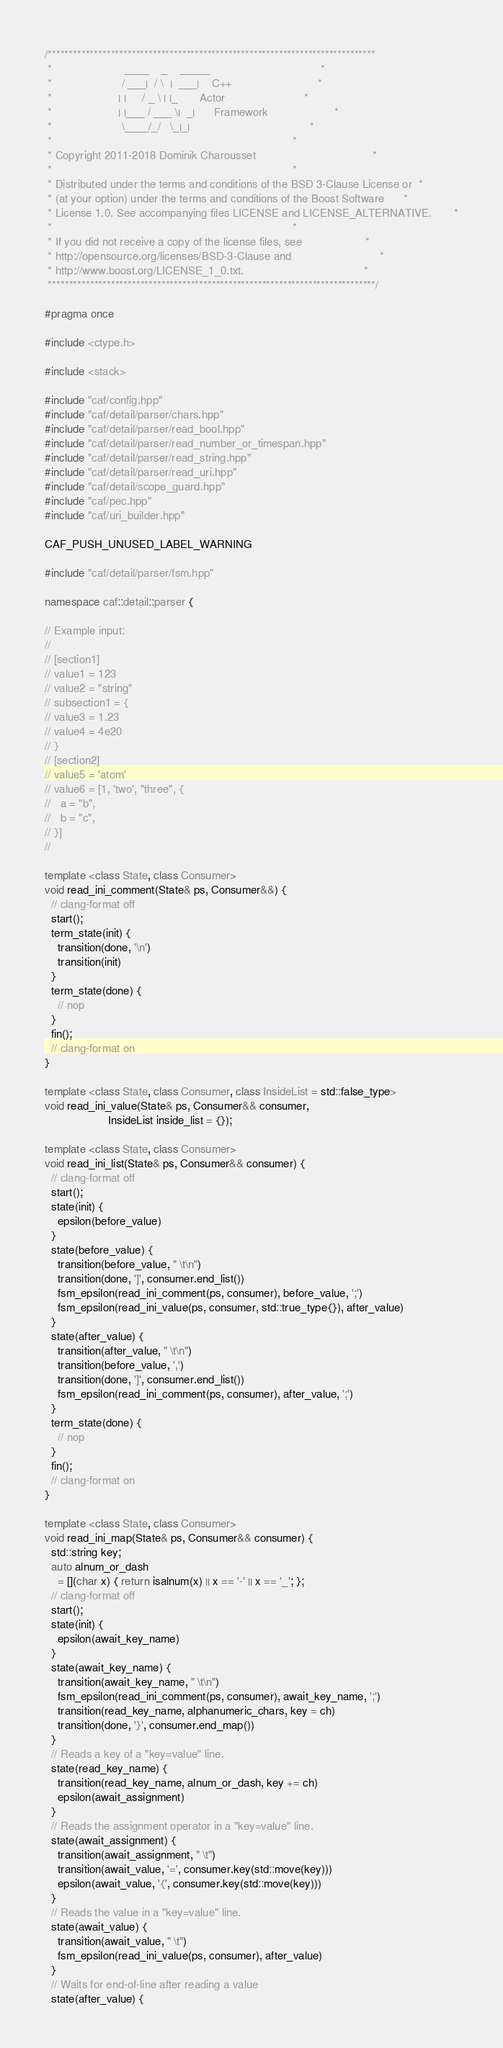Convert code to text. <code><loc_0><loc_0><loc_500><loc_500><_C++_>/******************************************************************************
 *                       ____    _    _____                                   *
 *                      / ___|  / \  |  ___|    C++                           *
 *                     | |     / _ \ | |_       Actor                         *
 *                     | |___ / ___ \|  _|      Framework                     *
 *                      \____/_/   \_|_|                                      *
 *                                                                            *
 * Copyright 2011-2018 Dominik Charousset                                     *
 *                                                                            *
 * Distributed under the terms and conditions of the BSD 3-Clause License or  *
 * (at your option) under the terms and conditions of the Boost Software      *
 * License 1.0. See accompanying files LICENSE and LICENSE_ALTERNATIVE.       *
 *                                                                            *
 * If you did not receive a copy of the license files, see                    *
 * http://opensource.org/licenses/BSD-3-Clause and                            *
 * http://www.boost.org/LICENSE_1_0.txt.                                      *
 ******************************************************************************/

#pragma once

#include <ctype.h>

#include <stack>

#include "caf/config.hpp"
#include "caf/detail/parser/chars.hpp"
#include "caf/detail/parser/read_bool.hpp"
#include "caf/detail/parser/read_number_or_timespan.hpp"
#include "caf/detail/parser/read_string.hpp"
#include "caf/detail/parser/read_uri.hpp"
#include "caf/detail/scope_guard.hpp"
#include "caf/pec.hpp"
#include "caf/uri_builder.hpp"

CAF_PUSH_UNUSED_LABEL_WARNING

#include "caf/detail/parser/fsm.hpp"

namespace caf::detail::parser {

// Example input:
//
// [section1]
// value1 = 123
// value2 = "string"
// subsection1 = {
// value3 = 1.23
// value4 = 4e20
// }
// [section2]
// value5 = 'atom'
// value6 = [1, 'two', "three", {
//   a = "b",
//   b = "c",
// }]
//

template <class State, class Consumer>
void read_ini_comment(State& ps, Consumer&&) {
  // clang-format off
  start();
  term_state(init) {
    transition(done, '\n')
    transition(init)
  }
  term_state(done) {
    // nop
  }
  fin();
  // clang-format on
}

template <class State, class Consumer, class InsideList = std::false_type>
void read_ini_value(State& ps, Consumer&& consumer,
                    InsideList inside_list = {});

template <class State, class Consumer>
void read_ini_list(State& ps, Consumer&& consumer) {
  // clang-format off
  start();
  state(init) {
    epsilon(before_value)
  }
  state(before_value) {
    transition(before_value, " \t\n")
    transition(done, ']', consumer.end_list())
    fsm_epsilon(read_ini_comment(ps, consumer), before_value, ';')
    fsm_epsilon(read_ini_value(ps, consumer, std::true_type{}), after_value)
  }
  state(after_value) {
    transition(after_value, " \t\n")
    transition(before_value, ',')
    transition(done, ']', consumer.end_list())
    fsm_epsilon(read_ini_comment(ps, consumer), after_value, ';')
  }
  term_state(done) {
    // nop
  }
  fin();
  // clang-format on
}

template <class State, class Consumer>
void read_ini_map(State& ps, Consumer&& consumer) {
  std::string key;
  auto alnum_or_dash
    = [](char x) { return isalnum(x) || x == '-' || x == '_'; };
  // clang-format off
  start();
  state(init) {
    epsilon(await_key_name)
  }
  state(await_key_name) {
    transition(await_key_name, " \t\n")
    fsm_epsilon(read_ini_comment(ps, consumer), await_key_name, ';')
    transition(read_key_name, alphanumeric_chars, key = ch)
    transition(done, '}', consumer.end_map())
  }
  // Reads a key of a "key=value" line.
  state(read_key_name) {
    transition(read_key_name, alnum_or_dash, key += ch)
    epsilon(await_assignment)
  }
  // Reads the assignment operator in a "key=value" line.
  state(await_assignment) {
    transition(await_assignment, " \t")
    transition(await_value, '=', consumer.key(std::move(key)))
    epsilon(await_value, '{', consumer.key(std::move(key)))
  }
  // Reads the value in a "key=value" line.
  state(await_value) {
    transition(await_value, " \t")
    fsm_epsilon(read_ini_value(ps, consumer), after_value)
  }
  // Waits for end-of-line after reading a value
  state(after_value) {</code> 